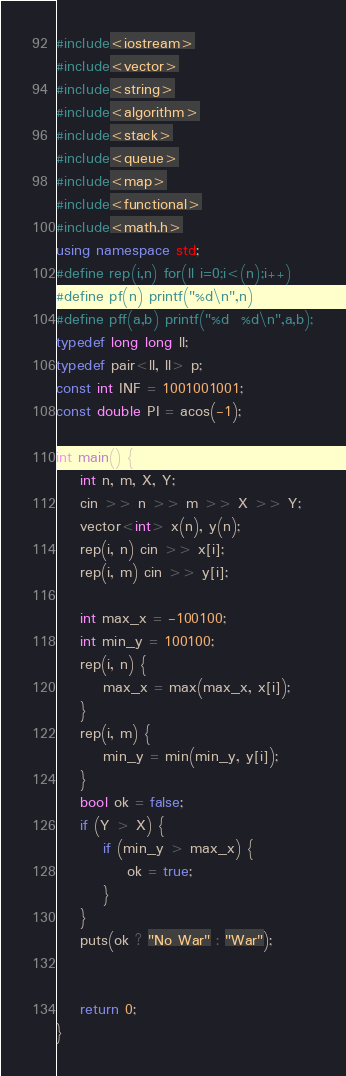<code> <loc_0><loc_0><loc_500><loc_500><_C++_>#include<iostream>
#include<vector>
#include<string>
#include<algorithm>
#include<stack>
#include<queue>
#include<map>
#include<functional>
#include<math.h>
using namespace std;
#define rep(i,n) for(ll i=0;i<(n);i++)
#define pf(n) printf("%d\n",n)
#define pff(a,b) printf("%d  %d\n",a,b);
typedef long long ll;
typedef pair<ll, ll> p;
const int INF = 1001001001;
const double PI = acos(-1);

int main() {
	int n, m, X, Y;
	cin >> n >> m >> X >> Y;
	vector<int> x(n), y(n);
	rep(i, n) cin >> x[i];
	rep(i, m) cin >> y[i];

	int max_x = -100100;
	int min_y = 100100;
	rep(i, n) {
		max_x = max(max_x, x[i]);
	}
	rep(i, m) {
		min_y = min(min_y, y[i]);
	}
	bool ok = false;
	if (Y > X) {
		if (min_y > max_x) {
			ok = true;
		}
	}
	puts(ok ? "No War" : "War");


	return 0;
}</code> 